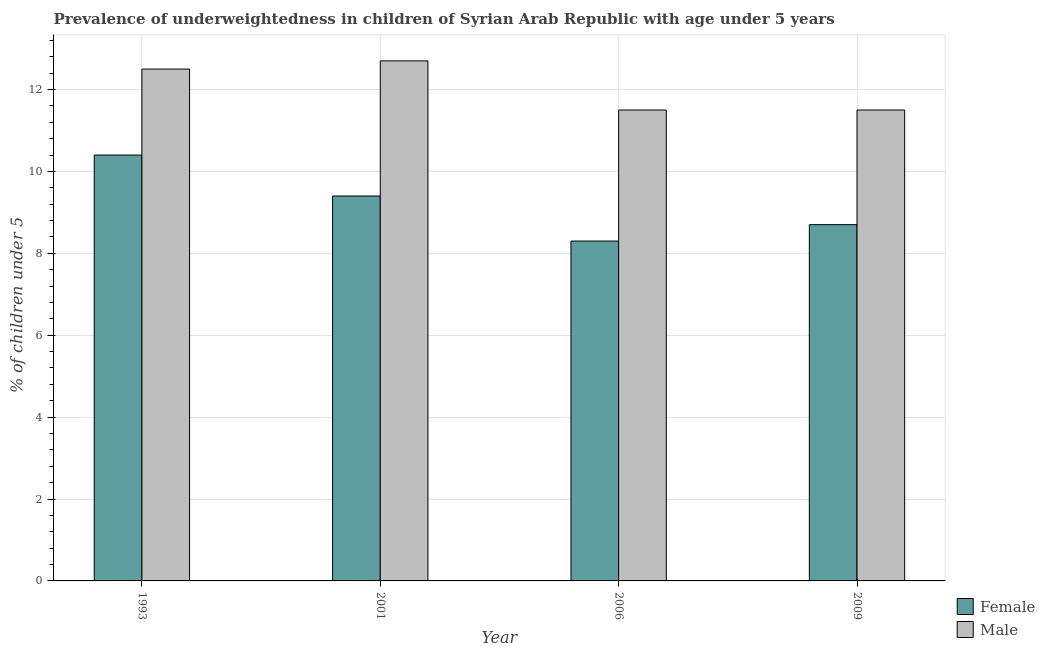How many different coloured bars are there?
Keep it short and to the point. 2. How many groups of bars are there?
Offer a terse response. 4. Are the number of bars per tick equal to the number of legend labels?
Provide a short and direct response. Yes. How many bars are there on the 1st tick from the left?
Give a very brief answer. 2. How many bars are there on the 4th tick from the right?
Make the answer very short. 2. What is the percentage of underweighted male children in 1993?
Your response must be concise. 12.5. Across all years, what is the maximum percentage of underweighted male children?
Provide a short and direct response. 12.7. Across all years, what is the minimum percentage of underweighted female children?
Your response must be concise. 8.3. In which year was the percentage of underweighted female children minimum?
Ensure brevity in your answer.  2006. What is the total percentage of underweighted male children in the graph?
Provide a short and direct response. 48.2. What is the difference between the percentage of underweighted female children in 2006 and that in 2009?
Offer a very short reply. -0.4. What is the average percentage of underweighted male children per year?
Your answer should be very brief. 12.05. In the year 2009, what is the difference between the percentage of underweighted male children and percentage of underweighted female children?
Provide a short and direct response. 0. What is the ratio of the percentage of underweighted male children in 2001 to that in 2006?
Make the answer very short. 1.1. Is the percentage of underweighted male children in 1993 less than that in 2009?
Ensure brevity in your answer.  No. Is the difference between the percentage of underweighted male children in 1993 and 2001 greater than the difference between the percentage of underweighted female children in 1993 and 2001?
Provide a short and direct response. No. What is the difference between the highest and the second highest percentage of underweighted female children?
Give a very brief answer. 1. What is the difference between the highest and the lowest percentage of underweighted male children?
Ensure brevity in your answer.  1.2. Is the sum of the percentage of underweighted female children in 2006 and 2009 greater than the maximum percentage of underweighted male children across all years?
Your answer should be very brief. Yes. What does the 1st bar from the right in 1993 represents?
Offer a terse response. Male. How many bars are there?
Your response must be concise. 8. Are all the bars in the graph horizontal?
Your answer should be very brief. No. Does the graph contain any zero values?
Ensure brevity in your answer.  No. Does the graph contain grids?
Ensure brevity in your answer.  Yes. Where does the legend appear in the graph?
Offer a terse response. Bottom right. What is the title of the graph?
Keep it short and to the point. Prevalence of underweightedness in children of Syrian Arab Republic with age under 5 years. Does "Non-solid fuel" appear as one of the legend labels in the graph?
Make the answer very short. No. What is the label or title of the Y-axis?
Provide a short and direct response.  % of children under 5. What is the  % of children under 5 in Female in 1993?
Your response must be concise. 10.4. What is the  % of children under 5 of Male in 1993?
Give a very brief answer. 12.5. What is the  % of children under 5 in Female in 2001?
Ensure brevity in your answer.  9.4. What is the  % of children under 5 in Male in 2001?
Offer a terse response. 12.7. What is the  % of children under 5 in Female in 2006?
Offer a terse response. 8.3. What is the  % of children under 5 in Male in 2006?
Give a very brief answer. 11.5. What is the  % of children under 5 of Female in 2009?
Offer a terse response. 8.7. Across all years, what is the maximum  % of children under 5 in Female?
Provide a short and direct response. 10.4. Across all years, what is the maximum  % of children under 5 of Male?
Offer a very short reply. 12.7. Across all years, what is the minimum  % of children under 5 in Female?
Offer a terse response. 8.3. Across all years, what is the minimum  % of children under 5 in Male?
Provide a short and direct response. 11.5. What is the total  % of children under 5 in Female in the graph?
Give a very brief answer. 36.8. What is the total  % of children under 5 of Male in the graph?
Your answer should be very brief. 48.2. What is the difference between the  % of children under 5 of Male in 1993 and that in 2001?
Your answer should be very brief. -0.2. What is the difference between the  % of children under 5 of Female in 1993 and that in 2006?
Provide a short and direct response. 2.1. What is the difference between the  % of children under 5 of Female in 2001 and that in 2006?
Provide a succinct answer. 1.1. What is the difference between the  % of children under 5 in Male in 2001 and that in 2009?
Provide a short and direct response. 1.2. What is the difference between the  % of children under 5 of Female in 2006 and that in 2009?
Give a very brief answer. -0.4. What is the difference between the  % of children under 5 in Female in 1993 and the  % of children under 5 in Male in 2009?
Offer a terse response. -1.1. What is the difference between the  % of children under 5 of Female in 2001 and the  % of children under 5 of Male in 2006?
Your response must be concise. -2.1. What is the difference between the  % of children under 5 of Female in 2006 and the  % of children under 5 of Male in 2009?
Keep it short and to the point. -3.2. What is the average  % of children under 5 of Male per year?
Your answer should be compact. 12.05. What is the ratio of the  % of children under 5 of Female in 1993 to that in 2001?
Provide a succinct answer. 1.11. What is the ratio of the  % of children under 5 of Male in 1993 to that in 2001?
Give a very brief answer. 0.98. What is the ratio of the  % of children under 5 in Female in 1993 to that in 2006?
Offer a terse response. 1.25. What is the ratio of the  % of children under 5 in Male in 1993 to that in 2006?
Your answer should be compact. 1.09. What is the ratio of the  % of children under 5 of Female in 1993 to that in 2009?
Offer a terse response. 1.2. What is the ratio of the  % of children under 5 of Male in 1993 to that in 2009?
Your answer should be compact. 1.09. What is the ratio of the  % of children under 5 in Female in 2001 to that in 2006?
Your answer should be compact. 1.13. What is the ratio of the  % of children under 5 of Male in 2001 to that in 2006?
Give a very brief answer. 1.1. What is the ratio of the  % of children under 5 of Female in 2001 to that in 2009?
Provide a short and direct response. 1.08. What is the ratio of the  % of children under 5 in Male in 2001 to that in 2009?
Provide a short and direct response. 1.1. What is the ratio of the  % of children under 5 of Female in 2006 to that in 2009?
Offer a very short reply. 0.95. What is the difference between the highest and the second highest  % of children under 5 of Male?
Your answer should be compact. 0.2. What is the difference between the highest and the lowest  % of children under 5 in Male?
Your answer should be very brief. 1.2. 